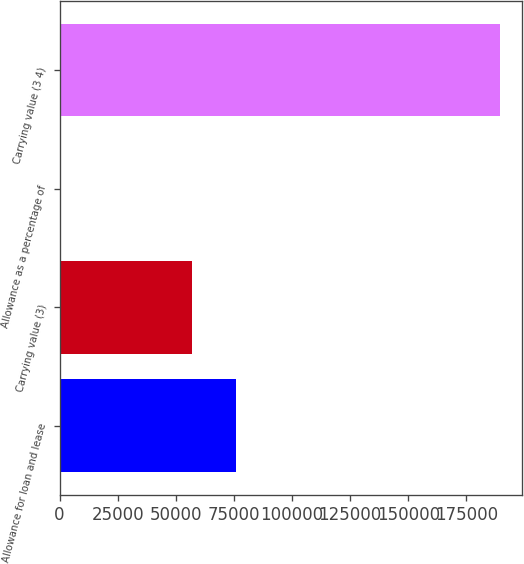<chart> <loc_0><loc_0><loc_500><loc_500><bar_chart><fcel>Allowance for loan and lease<fcel>Carrying value (3)<fcel>Allowance as a percentage of<fcel>Carrying value (3 4)<nl><fcel>75865<fcel>56899.2<fcel>1.7<fcel>189660<nl></chart> 